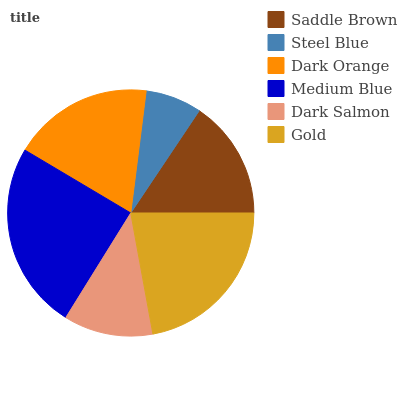Is Steel Blue the minimum?
Answer yes or no. Yes. Is Medium Blue the maximum?
Answer yes or no. Yes. Is Dark Orange the minimum?
Answer yes or no. No. Is Dark Orange the maximum?
Answer yes or no. No. Is Dark Orange greater than Steel Blue?
Answer yes or no. Yes. Is Steel Blue less than Dark Orange?
Answer yes or no. Yes. Is Steel Blue greater than Dark Orange?
Answer yes or no. No. Is Dark Orange less than Steel Blue?
Answer yes or no. No. Is Dark Orange the high median?
Answer yes or no. Yes. Is Saddle Brown the low median?
Answer yes or no. Yes. Is Medium Blue the high median?
Answer yes or no. No. Is Gold the low median?
Answer yes or no. No. 